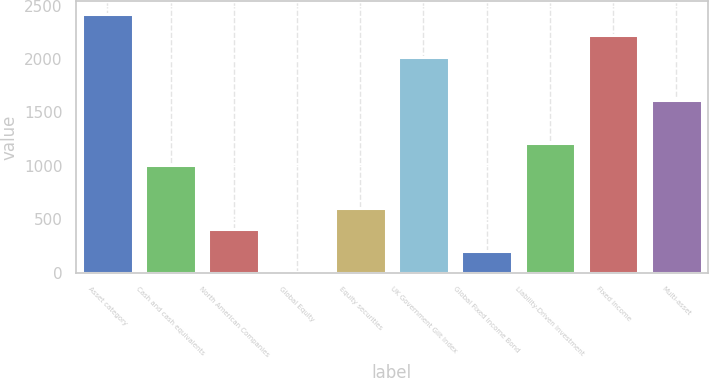Convert chart. <chart><loc_0><loc_0><loc_500><loc_500><bar_chart><fcel>Asset category<fcel>Cash and cash equivalents<fcel>North American Companies<fcel>Global Equity<fcel>Equity securities<fcel>UK Government Gilt Index<fcel>Global Fixed Income Bond<fcel>Liability-Driven Investment<fcel>Fixed income<fcel>Multi-asset<nl><fcel>2421.2<fcel>1010<fcel>405.2<fcel>2<fcel>606.8<fcel>2018<fcel>203.6<fcel>1211.6<fcel>2219.6<fcel>1614.8<nl></chart> 